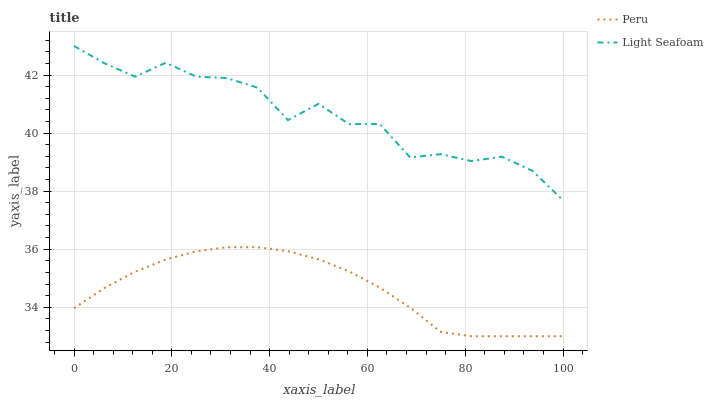Does Peru have the minimum area under the curve?
Answer yes or no. Yes. Does Light Seafoam have the maximum area under the curve?
Answer yes or no. Yes. Does Peru have the maximum area under the curve?
Answer yes or no. No. Is Peru the smoothest?
Answer yes or no. Yes. Is Light Seafoam the roughest?
Answer yes or no. Yes. Is Peru the roughest?
Answer yes or no. No. Does Peru have the lowest value?
Answer yes or no. Yes. Does Light Seafoam have the highest value?
Answer yes or no. Yes. Does Peru have the highest value?
Answer yes or no. No. Is Peru less than Light Seafoam?
Answer yes or no. Yes. Is Light Seafoam greater than Peru?
Answer yes or no. Yes. Does Peru intersect Light Seafoam?
Answer yes or no. No. 